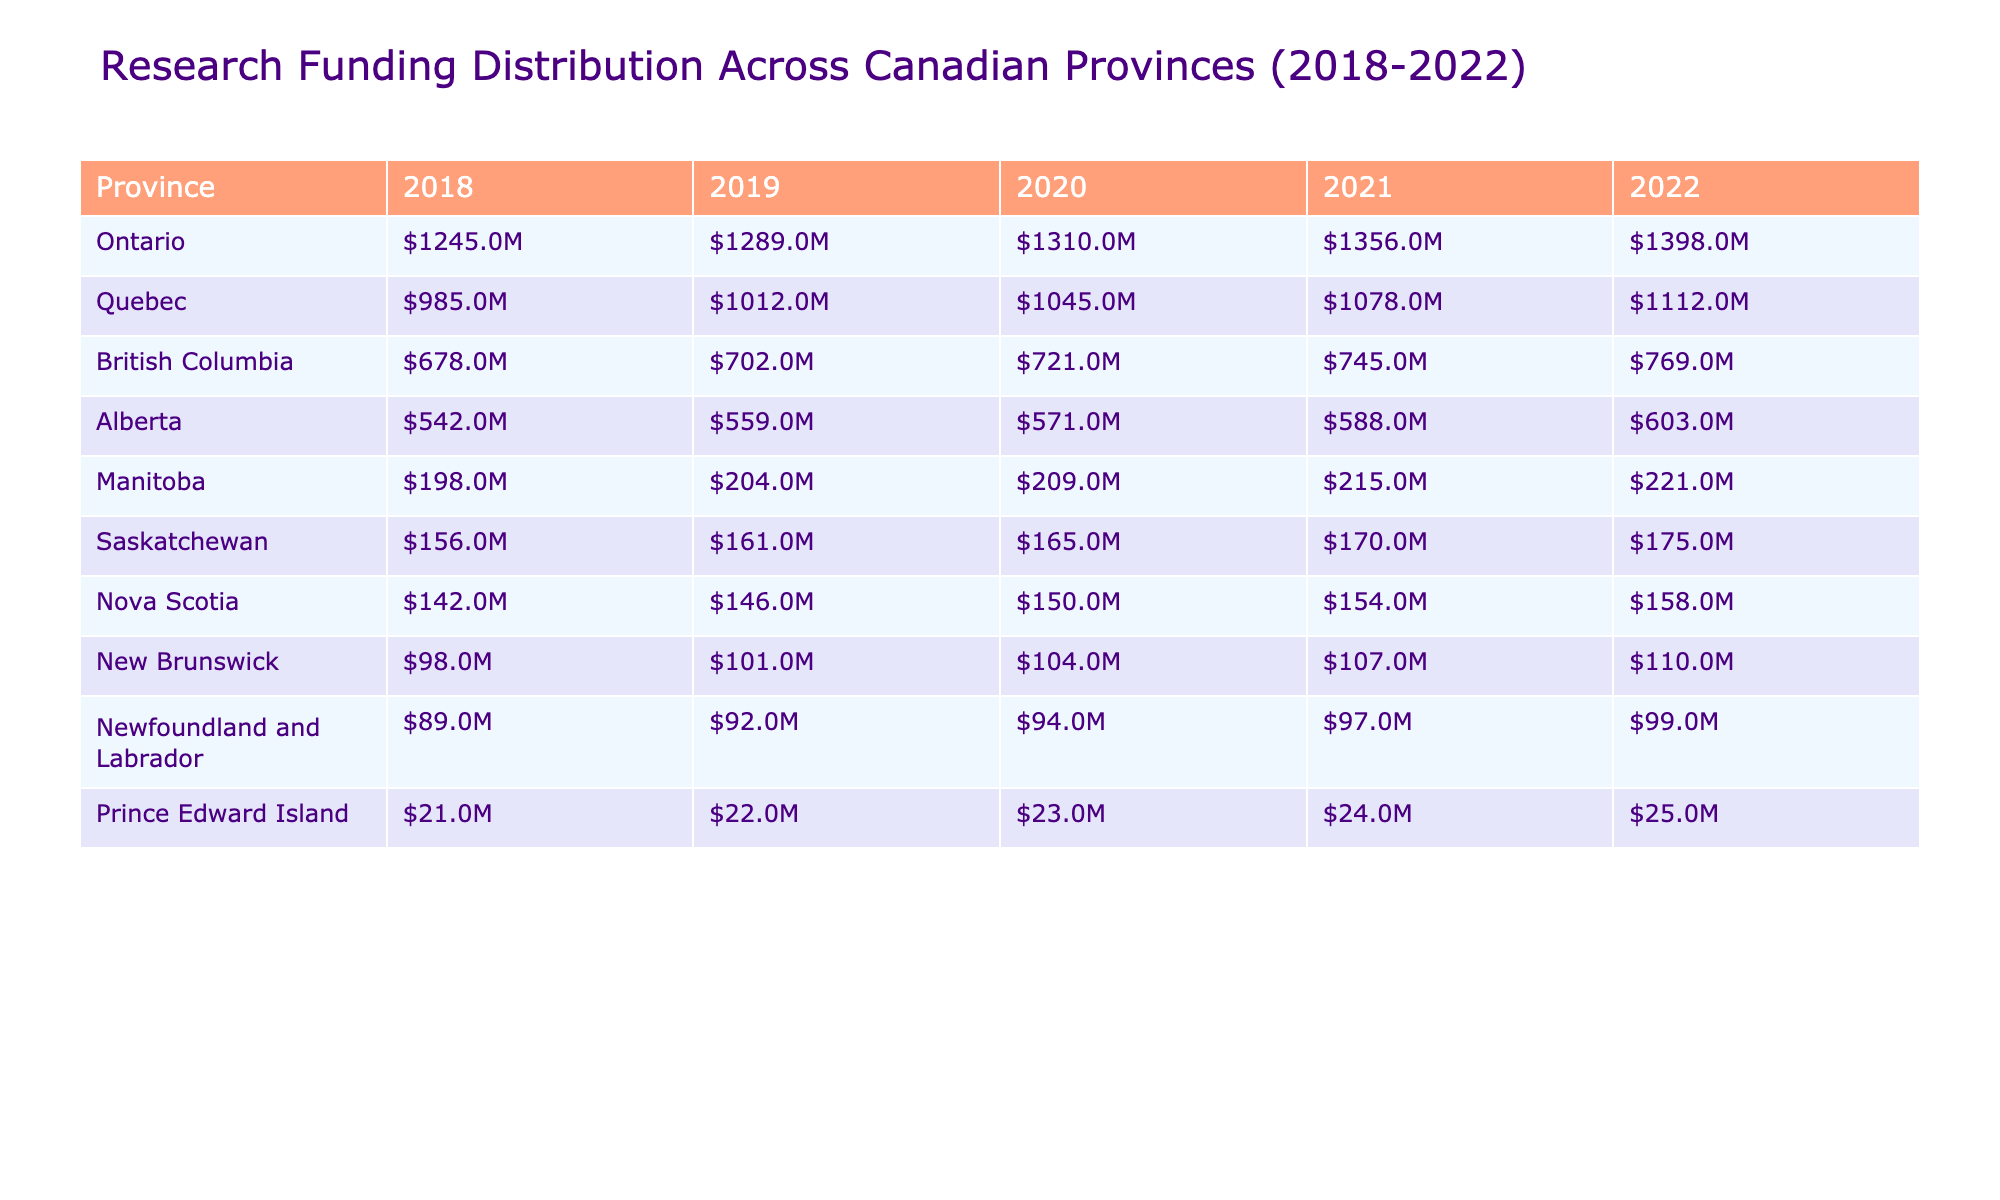What was the research funding for Ontario in 2021? The table shows that Ontario received $1,356,000,000 in research funding in 2021.
Answer: $1,356,000,000 What is the total research funding in British Columbia from 2018 to 2022? To find this, we sum the values for British Columbia: 678,000,000 + 702,000,000 + 721,000,000 + 745,000,000 + 769,000,000 = 3,615,000,000.
Answer: $3,615,000,000 Did Alberta receive more funding in 2022 than in 2020? Comparing the values, Alberta received $603,000,000 in 2022 and $571,000,000 in 2020. Since $603,000,000 is greater than $571,000,000, the statement is true.
Answer: Yes Which province had the highest research funding in 2022, and what was the amount? By examining the values for 2022, Ontario had the highest funding amount of $1,398,000,000, compared to other provinces.
Answer: Ontario, $1,398,000,000 What is the average research funding for all provinces in 2021? First, sum the values for all provinces in 2021: 1,356 + 1,078 + 745 + 588 + 215 + 170 + 154 + 107 + 97 + 25 = 4,960. Then, divide by the number of provinces (10): 4,960 / 10 = 496.
Answer: $496,000,000 Is the increase in research funding for Nova Scotia from 2018 to 2022 greater than $15,000,000? Nova Scotia's funding grew from $142,000,000 in 2018 to $158,000,000 in 2022. The increase is $158,000,000 - $142,000,000 = $16,000,000, which is greater than $15,000,000.
Answer: Yes What is the difference in research funding between Quebec and Manitoba in 2022? In 2022, Quebec received $1,112,000,000 and Manitoba received $221,000,000. The difference is $1,112,000,000 - $221,000,000 = $891,000,000.
Answer: $891,000,000 What percentage of the total funding for New Brunswick in 2022 does Newfoundland and Labrador represent? New Brunswick had $110,000,000 and Newfoundland and Labrador had $99,000,000 in 2022. To find the percentage: (99,000,000 / 110,000,000) * 100 = 90%.
Answer: 90% Which province had the smallest funding in 2020 and what was that amount? In 2020, Prince Edward Island had the smallest funding amount of $23,000,000, compared to other provinces.
Answer: Prince Edward Island, $23,000,000 If we consider the average funding for the four western provinces in 2022, what would that average be? The four western provinces and their 2022 funding are: British Columbia ($769,000,000), Alberta ($603,000,000), Saskatchewan ($175,000,000), and Manitoba ($221,000,000). The total is $769 + $603 + $175 + $221 = $1,768,000,000. The average for 4 provinces is $1,768,000,000 / 4 = $442,000,000.
Answer: $442,000,000 